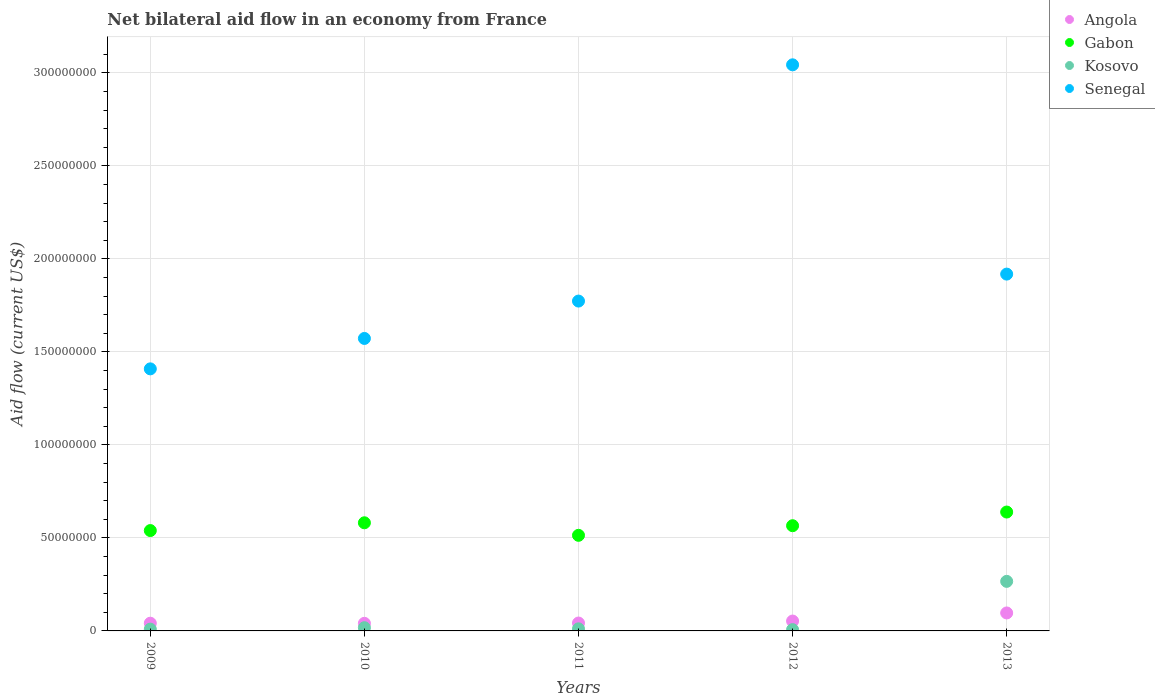How many different coloured dotlines are there?
Make the answer very short. 4. What is the net bilateral aid flow in Angola in 2011?
Your response must be concise. 4.24e+06. Across all years, what is the maximum net bilateral aid flow in Angola?
Offer a very short reply. 9.66e+06. Across all years, what is the minimum net bilateral aid flow in Angola?
Give a very brief answer. 4.09e+06. In which year was the net bilateral aid flow in Gabon minimum?
Your answer should be very brief. 2011. What is the total net bilateral aid flow in Angola in the graph?
Keep it short and to the point. 2.74e+07. What is the difference between the net bilateral aid flow in Angola in 2011 and that in 2013?
Provide a succinct answer. -5.42e+06. What is the difference between the net bilateral aid flow in Angola in 2011 and the net bilateral aid flow in Senegal in 2010?
Provide a succinct answer. -1.53e+08. What is the average net bilateral aid flow in Senegal per year?
Your answer should be compact. 1.94e+08. In the year 2010, what is the difference between the net bilateral aid flow in Gabon and net bilateral aid flow in Senegal?
Provide a succinct answer. -9.91e+07. What is the ratio of the net bilateral aid flow in Angola in 2010 to that in 2013?
Give a very brief answer. 0.42. What is the difference between the highest and the second highest net bilateral aid flow in Senegal?
Give a very brief answer. 1.13e+08. What is the difference between the highest and the lowest net bilateral aid flow in Senegal?
Your answer should be compact. 1.63e+08. Is the sum of the net bilateral aid flow in Angola in 2010 and 2012 greater than the maximum net bilateral aid flow in Senegal across all years?
Keep it short and to the point. No. Is it the case that in every year, the sum of the net bilateral aid flow in Senegal and net bilateral aid flow in Kosovo  is greater than the sum of net bilateral aid flow in Angola and net bilateral aid flow in Gabon?
Ensure brevity in your answer.  No. Is it the case that in every year, the sum of the net bilateral aid flow in Angola and net bilateral aid flow in Kosovo  is greater than the net bilateral aid flow in Senegal?
Keep it short and to the point. No. What is the difference between two consecutive major ticks on the Y-axis?
Keep it short and to the point. 5.00e+07. Where does the legend appear in the graph?
Keep it short and to the point. Top right. How are the legend labels stacked?
Make the answer very short. Vertical. What is the title of the graph?
Make the answer very short. Net bilateral aid flow in an economy from France. Does "Swaziland" appear as one of the legend labels in the graph?
Offer a very short reply. No. What is the Aid flow (current US$) of Angola in 2009?
Your response must be concise. 4.15e+06. What is the Aid flow (current US$) in Gabon in 2009?
Make the answer very short. 5.40e+07. What is the Aid flow (current US$) in Kosovo in 2009?
Your answer should be very brief. 9.60e+05. What is the Aid flow (current US$) in Senegal in 2009?
Provide a short and direct response. 1.41e+08. What is the Aid flow (current US$) of Angola in 2010?
Your answer should be compact. 4.09e+06. What is the Aid flow (current US$) of Gabon in 2010?
Your answer should be compact. 5.81e+07. What is the Aid flow (current US$) in Kosovo in 2010?
Give a very brief answer. 1.73e+06. What is the Aid flow (current US$) of Senegal in 2010?
Your response must be concise. 1.57e+08. What is the Aid flow (current US$) in Angola in 2011?
Offer a very short reply. 4.24e+06. What is the Aid flow (current US$) of Gabon in 2011?
Ensure brevity in your answer.  5.14e+07. What is the Aid flow (current US$) in Kosovo in 2011?
Offer a very short reply. 1.12e+06. What is the Aid flow (current US$) in Senegal in 2011?
Give a very brief answer. 1.77e+08. What is the Aid flow (current US$) in Angola in 2012?
Offer a terse response. 5.31e+06. What is the Aid flow (current US$) in Gabon in 2012?
Make the answer very short. 5.66e+07. What is the Aid flow (current US$) in Kosovo in 2012?
Your answer should be compact. 6.90e+05. What is the Aid flow (current US$) in Senegal in 2012?
Offer a very short reply. 3.04e+08. What is the Aid flow (current US$) in Angola in 2013?
Provide a succinct answer. 9.66e+06. What is the Aid flow (current US$) in Gabon in 2013?
Your answer should be compact. 6.39e+07. What is the Aid flow (current US$) of Kosovo in 2013?
Make the answer very short. 2.66e+07. What is the Aid flow (current US$) in Senegal in 2013?
Your response must be concise. 1.92e+08. Across all years, what is the maximum Aid flow (current US$) of Angola?
Make the answer very short. 9.66e+06. Across all years, what is the maximum Aid flow (current US$) in Gabon?
Provide a short and direct response. 6.39e+07. Across all years, what is the maximum Aid flow (current US$) in Kosovo?
Keep it short and to the point. 2.66e+07. Across all years, what is the maximum Aid flow (current US$) of Senegal?
Your response must be concise. 3.04e+08. Across all years, what is the minimum Aid flow (current US$) of Angola?
Provide a short and direct response. 4.09e+06. Across all years, what is the minimum Aid flow (current US$) in Gabon?
Offer a terse response. 5.14e+07. Across all years, what is the minimum Aid flow (current US$) in Kosovo?
Your response must be concise. 6.90e+05. Across all years, what is the minimum Aid flow (current US$) in Senegal?
Offer a terse response. 1.41e+08. What is the total Aid flow (current US$) in Angola in the graph?
Provide a short and direct response. 2.74e+07. What is the total Aid flow (current US$) in Gabon in the graph?
Provide a short and direct response. 2.84e+08. What is the total Aid flow (current US$) of Kosovo in the graph?
Your answer should be very brief. 3.11e+07. What is the total Aid flow (current US$) in Senegal in the graph?
Your answer should be very brief. 9.72e+08. What is the difference between the Aid flow (current US$) of Angola in 2009 and that in 2010?
Provide a succinct answer. 6.00e+04. What is the difference between the Aid flow (current US$) in Gabon in 2009 and that in 2010?
Provide a short and direct response. -4.18e+06. What is the difference between the Aid flow (current US$) in Kosovo in 2009 and that in 2010?
Offer a terse response. -7.70e+05. What is the difference between the Aid flow (current US$) in Senegal in 2009 and that in 2010?
Offer a terse response. -1.64e+07. What is the difference between the Aid flow (current US$) in Gabon in 2009 and that in 2011?
Give a very brief answer. 2.56e+06. What is the difference between the Aid flow (current US$) of Kosovo in 2009 and that in 2011?
Provide a short and direct response. -1.60e+05. What is the difference between the Aid flow (current US$) in Senegal in 2009 and that in 2011?
Ensure brevity in your answer.  -3.64e+07. What is the difference between the Aid flow (current US$) in Angola in 2009 and that in 2012?
Your answer should be very brief. -1.16e+06. What is the difference between the Aid flow (current US$) of Gabon in 2009 and that in 2012?
Your answer should be compact. -2.61e+06. What is the difference between the Aid flow (current US$) in Senegal in 2009 and that in 2012?
Your answer should be compact. -1.63e+08. What is the difference between the Aid flow (current US$) of Angola in 2009 and that in 2013?
Give a very brief answer. -5.51e+06. What is the difference between the Aid flow (current US$) of Gabon in 2009 and that in 2013?
Your response must be concise. -9.96e+06. What is the difference between the Aid flow (current US$) of Kosovo in 2009 and that in 2013?
Keep it short and to the point. -2.57e+07. What is the difference between the Aid flow (current US$) in Senegal in 2009 and that in 2013?
Keep it short and to the point. -5.09e+07. What is the difference between the Aid flow (current US$) in Gabon in 2010 and that in 2011?
Keep it short and to the point. 6.74e+06. What is the difference between the Aid flow (current US$) in Senegal in 2010 and that in 2011?
Provide a short and direct response. -2.01e+07. What is the difference between the Aid flow (current US$) of Angola in 2010 and that in 2012?
Keep it short and to the point. -1.22e+06. What is the difference between the Aid flow (current US$) of Gabon in 2010 and that in 2012?
Your answer should be compact. 1.57e+06. What is the difference between the Aid flow (current US$) of Kosovo in 2010 and that in 2012?
Offer a terse response. 1.04e+06. What is the difference between the Aid flow (current US$) of Senegal in 2010 and that in 2012?
Your answer should be compact. -1.47e+08. What is the difference between the Aid flow (current US$) of Angola in 2010 and that in 2013?
Provide a short and direct response. -5.57e+06. What is the difference between the Aid flow (current US$) of Gabon in 2010 and that in 2013?
Ensure brevity in your answer.  -5.78e+06. What is the difference between the Aid flow (current US$) in Kosovo in 2010 and that in 2013?
Make the answer very short. -2.49e+07. What is the difference between the Aid flow (current US$) in Senegal in 2010 and that in 2013?
Your answer should be very brief. -3.46e+07. What is the difference between the Aid flow (current US$) of Angola in 2011 and that in 2012?
Ensure brevity in your answer.  -1.07e+06. What is the difference between the Aid flow (current US$) of Gabon in 2011 and that in 2012?
Your response must be concise. -5.17e+06. What is the difference between the Aid flow (current US$) of Senegal in 2011 and that in 2012?
Your response must be concise. -1.27e+08. What is the difference between the Aid flow (current US$) of Angola in 2011 and that in 2013?
Your answer should be compact. -5.42e+06. What is the difference between the Aid flow (current US$) in Gabon in 2011 and that in 2013?
Your answer should be compact. -1.25e+07. What is the difference between the Aid flow (current US$) in Kosovo in 2011 and that in 2013?
Offer a terse response. -2.55e+07. What is the difference between the Aid flow (current US$) of Senegal in 2011 and that in 2013?
Your answer should be compact. -1.45e+07. What is the difference between the Aid flow (current US$) of Angola in 2012 and that in 2013?
Your answer should be very brief. -4.35e+06. What is the difference between the Aid flow (current US$) of Gabon in 2012 and that in 2013?
Make the answer very short. -7.35e+06. What is the difference between the Aid flow (current US$) in Kosovo in 2012 and that in 2013?
Your response must be concise. -2.60e+07. What is the difference between the Aid flow (current US$) of Senegal in 2012 and that in 2013?
Keep it short and to the point. 1.13e+08. What is the difference between the Aid flow (current US$) in Angola in 2009 and the Aid flow (current US$) in Gabon in 2010?
Your response must be concise. -5.40e+07. What is the difference between the Aid flow (current US$) of Angola in 2009 and the Aid flow (current US$) of Kosovo in 2010?
Your response must be concise. 2.42e+06. What is the difference between the Aid flow (current US$) in Angola in 2009 and the Aid flow (current US$) in Senegal in 2010?
Your response must be concise. -1.53e+08. What is the difference between the Aid flow (current US$) of Gabon in 2009 and the Aid flow (current US$) of Kosovo in 2010?
Your answer should be very brief. 5.22e+07. What is the difference between the Aid flow (current US$) of Gabon in 2009 and the Aid flow (current US$) of Senegal in 2010?
Offer a very short reply. -1.03e+08. What is the difference between the Aid flow (current US$) in Kosovo in 2009 and the Aid flow (current US$) in Senegal in 2010?
Make the answer very short. -1.56e+08. What is the difference between the Aid flow (current US$) in Angola in 2009 and the Aid flow (current US$) in Gabon in 2011?
Provide a succinct answer. -4.72e+07. What is the difference between the Aid flow (current US$) of Angola in 2009 and the Aid flow (current US$) of Kosovo in 2011?
Your answer should be very brief. 3.03e+06. What is the difference between the Aid flow (current US$) in Angola in 2009 and the Aid flow (current US$) in Senegal in 2011?
Your answer should be compact. -1.73e+08. What is the difference between the Aid flow (current US$) of Gabon in 2009 and the Aid flow (current US$) of Kosovo in 2011?
Ensure brevity in your answer.  5.28e+07. What is the difference between the Aid flow (current US$) in Gabon in 2009 and the Aid flow (current US$) in Senegal in 2011?
Give a very brief answer. -1.23e+08. What is the difference between the Aid flow (current US$) of Kosovo in 2009 and the Aid flow (current US$) of Senegal in 2011?
Keep it short and to the point. -1.76e+08. What is the difference between the Aid flow (current US$) in Angola in 2009 and the Aid flow (current US$) in Gabon in 2012?
Make the answer very short. -5.24e+07. What is the difference between the Aid flow (current US$) in Angola in 2009 and the Aid flow (current US$) in Kosovo in 2012?
Your answer should be very brief. 3.46e+06. What is the difference between the Aid flow (current US$) in Angola in 2009 and the Aid flow (current US$) in Senegal in 2012?
Offer a terse response. -3.00e+08. What is the difference between the Aid flow (current US$) in Gabon in 2009 and the Aid flow (current US$) in Kosovo in 2012?
Your answer should be compact. 5.33e+07. What is the difference between the Aid flow (current US$) in Gabon in 2009 and the Aid flow (current US$) in Senegal in 2012?
Give a very brief answer. -2.50e+08. What is the difference between the Aid flow (current US$) of Kosovo in 2009 and the Aid flow (current US$) of Senegal in 2012?
Offer a terse response. -3.03e+08. What is the difference between the Aid flow (current US$) in Angola in 2009 and the Aid flow (current US$) in Gabon in 2013?
Your answer should be compact. -5.98e+07. What is the difference between the Aid flow (current US$) in Angola in 2009 and the Aid flow (current US$) in Kosovo in 2013?
Your answer should be very brief. -2.25e+07. What is the difference between the Aid flow (current US$) of Angola in 2009 and the Aid flow (current US$) of Senegal in 2013?
Provide a succinct answer. -1.88e+08. What is the difference between the Aid flow (current US$) in Gabon in 2009 and the Aid flow (current US$) in Kosovo in 2013?
Your response must be concise. 2.73e+07. What is the difference between the Aid flow (current US$) in Gabon in 2009 and the Aid flow (current US$) in Senegal in 2013?
Make the answer very short. -1.38e+08. What is the difference between the Aid flow (current US$) of Kosovo in 2009 and the Aid flow (current US$) of Senegal in 2013?
Offer a very short reply. -1.91e+08. What is the difference between the Aid flow (current US$) in Angola in 2010 and the Aid flow (current US$) in Gabon in 2011?
Offer a very short reply. -4.73e+07. What is the difference between the Aid flow (current US$) in Angola in 2010 and the Aid flow (current US$) in Kosovo in 2011?
Provide a succinct answer. 2.97e+06. What is the difference between the Aid flow (current US$) of Angola in 2010 and the Aid flow (current US$) of Senegal in 2011?
Offer a very short reply. -1.73e+08. What is the difference between the Aid flow (current US$) in Gabon in 2010 and the Aid flow (current US$) in Kosovo in 2011?
Your answer should be compact. 5.70e+07. What is the difference between the Aid flow (current US$) in Gabon in 2010 and the Aid flow (current US$) in Senegal in 2011?
Your answer should be very brief. -1.19e+08. What is the difference between the Aid flow (current US$) of Kosovo in 2010 and the Aid flow (current US$) of Senegal in 2011?
Give a very brief answer. -1.76e+08. What is the difference between the Aid flow (current US$) of Angola in 2010 and the Aid flow (current US$) of Gabon in 2012?
Your response must be concise. -5.25e+07. What is the difference between the Aid flow (current US$) in Angola in 2010 and the Aid flow (current US$) in Kosovo in 2012?
Ensure brevity in your answer.  3.40e+06. What is the difference between the Aid flow (current US$) of Angola in 2010 and the Aid flow (current US$) of Senegal in 2012?
Your answer should be compact. -3.00e+08. What is the difference between the Aid flow (current US$) of Gabon in 2010 and the Aid flow (current US$) of Kosovo in 2012?
Provide a short and direct response. 5.74e+07. What is the difference between the Aid flow (current US$) of Gabon in 2010 and the Aid flow (current US$) of Senegal in 2012?
Your response must be concise. -2.46e+08. What is the difference between the Aid flow (current US$) of Kosovo in 2010 and the Aid flow (current US$) of Senegal in 2012?
Offer a very short reply. -3.03e+08. What is the difference between the Aid flow (current US$) of Angola in 2010 and the Aid flow (current US$) of Gabon in 2013?
Offer a terse response. -5.98e+07. What is the difference between the Aid flow (current US$) of Angola in 2010 and the Aid flow (current US$) of Kosovo in 2013?
Offer a very short reply. -2.26e+07. What is the difference between the Aid flow (current US$) in Angola in 2010 and the Aid flow (current US$) in Senegal in 2013?
Make the answer very short. -1.88e+08. What is the difference between the Aid flow (current US$) in Gabon in 2010 and the Aid flow (current US$) in Kosovo in 2013?
Your answer should be compact. 3.15e+07. What is the difference between the Aid flow (current US$) in Gabon in 2010 and the Aid flow (current US$) in Senegal in 2013?
Make the answer very short. -1.34e+08. What is the difference between the Aid flow (current US$) in Kosovo in 2010 and the Aid flow (current US$) in Senegal in 2013?
Your response must be concise. -1.90e+08. What is the difference between the Aid flow (current US$) in Angola in 2011 and the Aid flow (current US$) in Gabon in 2012?
Offer a terse response. -5.23e+07. What is the difference between the Aid flow (current US$) in Angola in 2011 and the Aid flow (current US$) in Kosovo in 2012?
Provide a short and direct response. 3.55e+06. What is the difference between the Aid flow (current US$) in Angola in 2011 and the Aid flow (current US$) in Senegal in 2012?
Your response must be concise. -3.00e+08. What is the difference between the Aid flow (current US$) of Gabon in 2011 and the Aid flow (current US$) of Kosovo in 2012?
Give a very brief answer. 5.07e+07. What is the difference between the Aid flow (current US$) of Gabon in 2011 and the Aid flow (current US$) of Senegal in 2012?
Offer a very short reply. -2.53e+08. What is the difference between the Aid flow (current US$) in Kosovo in 2011 and the Aid flow (current US$) in Senegal in 2012?
Keep it short and to the point. -3.03e+08. What is the difference between the Aid flow (current US$) in Angola in 2011 and the Aid flow (current US$) in Gabon in 2013?
Ensure brevity in your answer.  -5.97e+07. What is the difference between the Aid flow (current US$) in Angola in 2011 and the Aid flow (current US$) in Kosovo in 2013?
Your answer should be very brief. -2.24e+07. What is the difference between the Aid flow (current US$) in Angola in 2011 and the Aid flow (current US$) in Senegal in 2013?
Provide a short and direct response. -1.88e+08. What is the difference between the Aid flow (current US$) of Gabon in 2011 and the Aid flow (current US$) of Kosovo in 2013?
Provide a succinct answer. 2.48e+07. What is the difference between the Aid flow (current US$) of Gabon in 2011 and the Aid flow (current US$) of Senegal in 2013?
Give a very brief answer. -1.40e+08. What is the difference between the Aid flow (current US$) in Kosovo in 2011 and the Aid flow (current US$) in Senegal in 2013?
Provide a succinct answer. -1.91e+08. What is the difference between the Aid flow (current US$) in Angola in 2012 and the Aid flow (current US$) in Gabon in 2013?
Make the answer very short. -5.86e+07. What is the difference between the Aid flow (current US$) of Angola in 2012 and the Aid flow (current US$) of Kosovo in 2013?
Provide a short and direct response. -2.13e+07. What is the difference between the Aid flow (current US$) of Angola in 2012 and the Aid flow (current US$) of Senegal in 2013?
Your answer should be compact. -1.87e+08. What is the difference between the Aid flow (current US$) in Gabon in 2012 and the Aid flow (current US$) in Kosovo in 2013?
Keep it short and to the point. 2.99e+07. What is the difference between the Aid flow (current US$) in Gabon in 2012 and the Aid flow (current US$) in Senegal in 2013?
Give a very brief answer. -1.35e+08. What is the difference between the Aid flow (current US$) of Kosovo in 2012 and the Aid flow (current US$) of Senegal in 2013?
Offer a terse response. -1.91e+08. What is the average Aid flow (current US$) in Angola per year?
Offer a very short reply. 5.49e+06. What is the average Aid flow (current US$) in Gabon per year?
Your answer should be compact. 5.68e+07. What is the average Aid flow (current US$) in Kosovo per year?
Offer a terse response. 6.23e+06. What is the average Aid flow (current US$) in Senegal per year?
Provide a short and direct response. 1.94e+08. In the year 2009, what is the difference between the Aid flow (current US$) of Angola and Aid flow (current US$) of Gabon?
Provide a short and direct response. -4.98e+07. In the year 2009, what is the difference between the Aid flow (current US$) of Angola and Aid flow (current US$) of Kosovo?
Keep it short and to the point. 3.19e+06. In the year 2009, what is the difference between the Aid flow (current US$) in Angola and Aid flow (current US$) in Senegal?
Provide a short and direct response. -1.37e+08. In the year 2009, what is the difference between the Aid flow (current US$) in Gabon and Aid flow (current US$) in Kosovo?
Give a very brief answer. 5.30e+07. In the year 2009, what is the difference between the Aid flow (current US$) in Gabon and Aid flow (current US$) in Senegal?
Your response must be concise. -8.69e+07. In the year 2009, what is the difference between the Aid flow (current US$) in Kosovo and Aid flow (current US$) in Senegal?
Keep it short and to the point. -1.40e+08. In the year 2010, what is the difference between the Aid flow (current US$) of Angola and Aid flow (current US$) of Gabon?
Your answer should be compact. -5.40e+07. In the year 2010, what is the difference between the Aid flow (current US$) of Angola and Aid flow (current US$) of Kosovo?
Offer a terse response. 2.36e+06. In the year 2010, what is the difference between the Aid flow (current US$) in Angola and Aid flow (current US$) in Senegal?
Provide a short and direct response. -1.53e+08. In the year 2010, what is the difference between the Aid flow (current US$) of Gabon and Aid flow (current US$) of Kosovo?
Offer a very short reply. 5.64e+07. In the year 2010, what is the difference between the Aid flow (current US$) in Gabon and Aid flow (current US$) in Senegal?
Offer a terse response. -9.91e+07. In the year 2010, what is the difference between the Aid flow (current US$) in Kosovo and Aid flow (current US$) in Senegal?
Your response must be concise. -1.56e+08. In the year 2011, what is the difference between the Aid flow (current US$) of Angola and Aid flow (current US$) of Gabon?
Provide a succinct answer. -4.72e+07. In the year 2011, what is the difference between the Aid flow (current US$) of Angola and Aid flow (current US$) of Kosovo?
Your answer should be very brief. 3.12e+06. In the year 2011, what is the difference between the Aid flow (current US$) in Angola and Aid flow (current US$) in Senegal?
Keep it short and to the point. -1.73e+08. In the year 2011, what is the difference between the Aid flow (current US$) in Gabon and Aid flow (current US$) in Kosovo?
Offer a terse response. 5.03e+07. In the year 2011, what is the difference between the Aid flow (current US$) of Gabon and Aid flow (current US$) of Senegal?
Offer a very short reply. -1.26e+08. In the year 2011, what is the difference between the Aid flow (current US$) of Kosovo and Aid flow (current US$) of Senegal?
Provide a short and direct response. -1.76e+08. In the year 2012, what is the difference between the Aid flow (current US$) of Angola and Aid flow (current US$) of Gabon?
Ensure brevity in your answer.  -5.12e+07. In the year 2012, what is the difference between the Aid flow (current US$) of Angola and Aid flow (current US$) of Kosovo?
Provide a short and direct response. 4.62e+06. In the year 2012, what is the difference between the Aid flow (current US$) in Angola and Aid flow (current US$) in Senegal?
Keep it short and to the point. -2.99e+08. In the year 2012, what is the difference between the Aid flow (current US$) of Gabon and Aid flow (current US$) of Kosovo?
Ensure brevity in your answer.  5.59e+07. In the year 2012, what is the difference between the Aid flow (current US$) in Gabon and Aid flow (current US$) in Senegal?
Provide a succinct answer. -2.48e+08. In the year 2012, what is the difference between the Aid flow (current US$) in Kosovo and Aid flow (current US$) in Senegal?
Give a very brief answer. -3.04e+08. In the year 2013, what is the difference between the Aid flow (current US$) in Angola and Aid flow (current US$) in Gabon?
Make the answer very short. -5.42e+07. In the year 2013, what is the difference between the Aid flow (current US$) of Angola and Aid flow (current US$) of Kosovo?
Provide a short and direct response. -1.70e+07. In the year 2013, what is the difference between the Aid flow (current US$) of Angola and Aid flow (current US$) of Senegal?
Your answer should be compact. -1.82e+08. In the year 2013, what is the difference between the Aid flow (current US$) of Gabon and Aid flow (current US$) of Kosovo?
Ensure brevity in your answer.  3.73e+07. In the year 2013, what is the difference between the Aid flow (current US$) of Gabon and Aid flow (current US$) of Senegal?
Offer a very short reply. -1.28e+08. In the year 2013, what is the difference between the Aid flow (current US$) in Kosovo and Aid flow (current US$) in Senegal?
Provide a succinct answer. -1.65e+08. What is the ratio of the Aid flow (current US$) of Angola in 2009 to that in 2010?
Give a very brief answer. 1.01. What is the ratio of the Aid flow (current US$) of Gabon in 2009 to that in 2010?
Provide a short and direct response. 0.93. What is the ratio of the Aid flow (current US$) of Kosovo in 2009 to that in 2010?
Your response must be concise. 0.55. What is the ratio of the Aid flow (current US$) in Senegal in 2009 to that in 2010?
Ensure brevity in your answer.  0.9. What is the ratio of the Aid flow (current US$) of Angola in 2009 to that in 2011?
Keep it short and to the point. 0.98. What is the ratio of the Aid flow (current US$) of Gabon in 2009 to that in 2011?
Provide a short and direct response. 1.05. What is the ratio of the Aid flow (current US$) in Senegal in 2009 to that in 2011?
Your response must be concise. 0.79. What is the ratio of the Aid flow (current US$) of Angola in 2009 to that in 2012?
Offer a terse response. 0.78. What is the ratio of the Aid flow (current US$) in Gabon in 2009 to that in 2012?
Your answer should be compact. 0.95. What is the ratio of the Aid flow (current US$) of Kosovo in 2009 to that in 2012?
Your response must be concise. 1.39. What is the ratio of the Aid flow (current US$) of Senegal in 2009 to that in 2012?
Provide a succinct answer. 0.46. What is the ratio of the Aid flow (current US$) of Angola in 2009 to that in 2013?
Provide a succinct answer. 0.43. What is the ratio of the Aid flow (current US$) of Gabon in 2009 to that in 2013?
Offer a very short reply. 0.84. What is the ratio of the Aid flow (current US$) of Kosovo in 2009 to that in 2013?
Keep it short and to the point. 0.04. What is the ratio of the Aid flow (current US$) of Senegal in 2009 to that in 2013?
Keep it short and to the point. 0.73. What is the ratio of the Aid flow (current US$) of Angola in 2010 to that in 2011?
Offer a terse response. 0.96. What is the ratio of the Aid flow (current US$) of Gabon in 2010 to that in 2011?
Ensure brevity in your answer.  1.13. What is the ratio of the Aid flow (current US$) of Kosovo in 2010 to that in 2011?
Ensure brevity in your answer.  1.54. What is the ratio of the Aid flow (current US$) in Senegal in 2010 to that in 2011?
Offer a very short reply. 0.89. What is the ratio of the Aid flow (current US$) of Angola in 2010 to that in 2012?
Offer a very short reply. 0.77. What is the ratio of the Aid flow (current US$) in Gabon in 2010 to that in 2012?
Offer a terse response. 1.03. What is the ratio of the Aid flow (current US$) of Kosovo in 2010 to that in 2012?
Your answer should be very brief. 2.51. What is the ratio of the Aid flow (current US$) of Senegal in 2010 to that in 2012?
Provide a succinct answer. 0.52. What is the ratio of the Aid flow (current US$) of Angola in 2010 to that in 2013?
Offer a very short reply. 0.42. What is the ratio of the Aid flow (current US$) of Gabon in 2010 to that in 2013?
Offer a very short reply. 0.91. What is the ratio of the Aid flow (current US$) in Kosovo in 2010 to that in 2013?
Provide a short and direct response. 0.06. What is the ratio of the Aid flow (current US$) of Senegal in 2010 to that in 2013?
Give a very brief answer. 0.82. What is the ratio of the Aid flow (current US$) of Angola in 2011 to that in 2012?
Your answer should be very brief. 0.8. What is the ratio of the Aid flow (current US$) of Gabon in 2011 to that in 2012?
Offer a terse response. 0.91. What is the ratio of the Aid flow (current US$) in Kosovo in 2011 to that in 2012?
Keep it short and to the point. 1.62. What is the ratio of the Aid flow (current US$) of Senegal in 2011 to that in 2012?
Your answer should be very brief. 0.58. What is the ratio of the Aid flow (current US$) of Angola in 2011 to that in 2013?
Ensure brevity in your answer.  0.44. What is the ratio of the Aid flow (current US$) in Gabon in 2011 to that in 2013?
Keep it short and to the point. 0.8. What is the ratio of the Aid flow (current US$) of Kosovo in 2011 to that in 2013?
Offer a very short reply. 0.04. What is the ratio of the Aid flow (current US$) of Senegal in 2011 to that in 2013?
Give a very brief answer. 0.92. What is the ratio of the Aid flow (current US$) of Angola in 2012 to that in 2013?
Your answer should be compact. 0.55. What is the ratio of the Aid flow (current US$) in Gabon in 2012 to that in 2013?
Give a very brief answer. 0.89. What is the ratio of the Aid flow (current US$) in Kosovo in 2012 to that in 2013?
Provide a succinct answer. 0.03. What is the ratio of the Aid flow (current US$) in Senegal in 2012 to that in 2013?
Keep it short and to the point. 1.59. What is the difference between the highest and the second highest Aid flow (current US$) in Angola?
Keep it short and to the point. 4.35e+06. What is the difference between the highest and the second highest Aid flow (current US$) in Gabon?
Keep it short and to the point. 5.78e+06. What is the difference between the highest and the second highest Aid flow (current US$) in Kosovo?
Provide a short and direct response. 2.49e+07. What is the difference between the highest and the second highest Aid flow (current US$) in Senegal?
Your answer should be very brief. 1.13e+08. What is the difference between the highest and the lowest Aid flow (current US$) in Angola?
Your response must be concise. 5.57e+06. What is the difference between the highest and the lowest Aid flow (current US$) of Gabon?
Give a very brief answer. 1.25e+07. What is the difference between the highest and the lowest Aid flow (current US$) in Kosovo?
Your answer should be very brief. 2.60e+07. What is the difference between the highest and the lowest Aid flow (current US$) in Senegal?
Keep it short and to the point. 1.63e+08. 